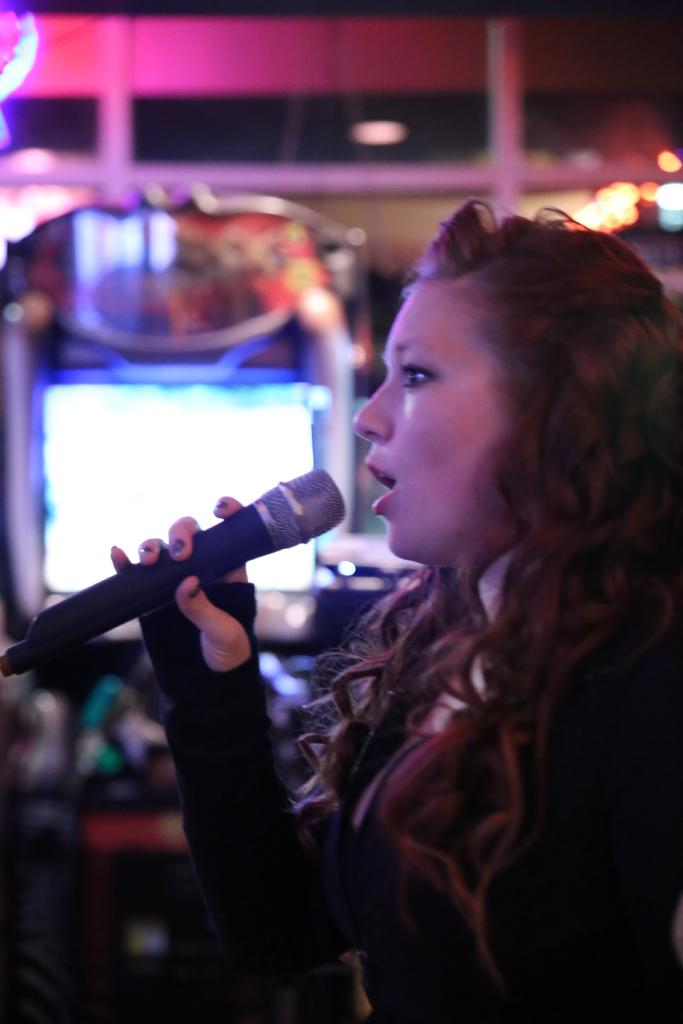What is the main subject of the image? The main subject of the image is a woman. What is the woman doing in the image? The woman is standing and holding a microphone. What might the woman be doing with the microphone? The woman might be singing. What can be seen in the background of the image? There appears to be a screen in the background of the image. How would you describe the image quality? The image quality is blurry. What advice does the woman give to the audience about the ongoing war in the image? There is no mention of a war or any advice being given in the image. The woman is holding a microphone, which might suggest she is singing or speaking, but there is no context provided about a war or any related advice. 